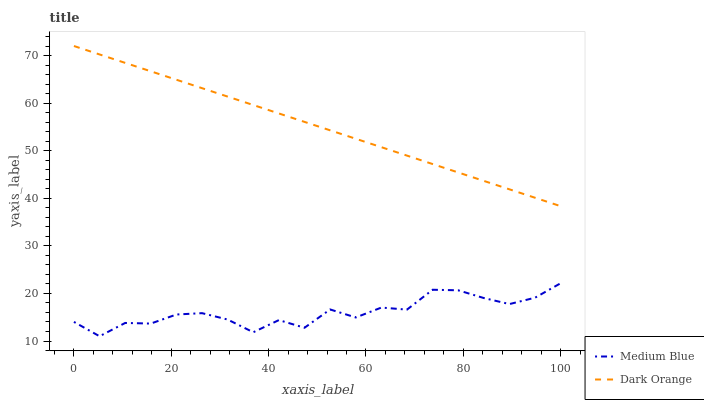Does Medium Blue have the minimum area under the curve?
Answer yes or no. Yes. Does Dark Orange have the maximum area under the curve?
Answer yes or no. Yes. Does Medium Blue have the maximum area under the curve?
Answer yes or no. No. Is Dark Orange the smoothest?
Answer yes or no. Yes. Is Medium Blue the roughest?
Answer yes or no. Yes. Is Medium Blue the smoothest?
Answer yes or no. No. Does Medium Blue have the lowest value?
Answer yes or no. Yes. Does Dark Orange have the highest value?
Answer yes or no. Yes. Does Medium Blue have the highest value?
Answer yes or no. No. Is Medium Blue less than Dark Orange?
Answer yes or no. Yes. Is Dark Orange greater than Medium Blue?
Answer yes or no. Yes. Does Medium Blue intersect Dark Orange?
Answer yes or no. No. 